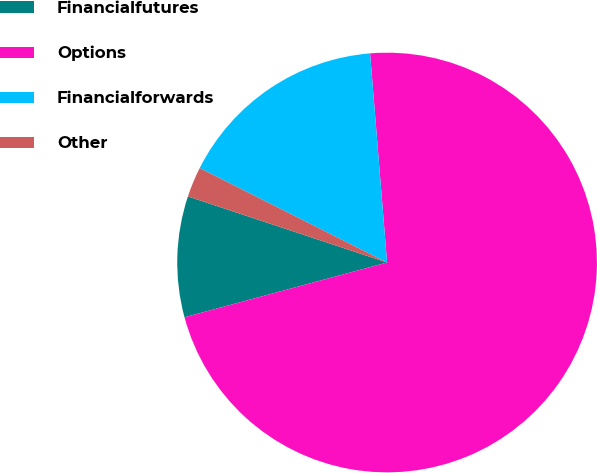Convert chart to OTSL. <chart><loc_0><loc_0><loc_500><loc_500><pie_chart><fcel>Financialfutures<fcel>Options<fcel>Financialforwards<fcel>Other<nl><fcel>9.3%<fcel>72.09%<fcel>16.28%<fcel>2.33%<nl></chart> 